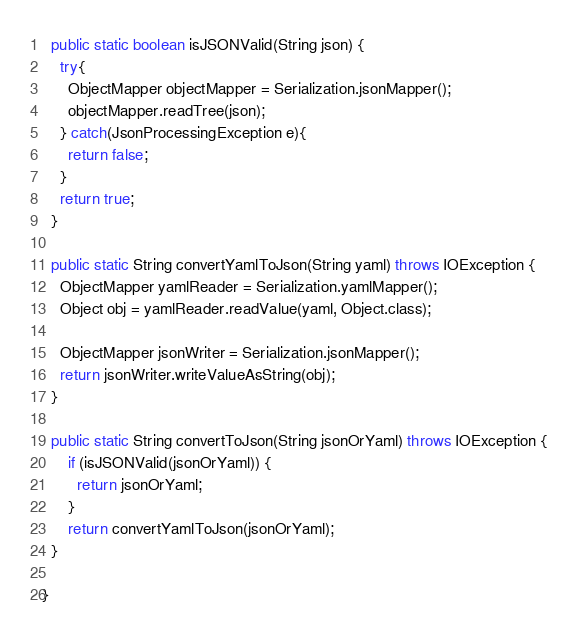Convert code to text. <code><loc_0><loc_0><loc_500><loc_500><_Java_>
  public static boolean isJSONValid(String json) {
    try{
      ObjectMapper objectMapper = Serialization.jsonMapper();
      objectMapper.readTree(json);
    } catch(JsonProcessingException e){
      return false;
    }
    return true;
  }

  public static String convertYamlToJson(String yaml) throws IOException {
    ObjectMapper yamlReader = Serialization.yamlMapper();
    Object obj = yamlReader.readValue(yaml, Object.class);

    ObjectMapper jsonWriter = Serialization.jsonMapper();
    return jsonWriter.writeValueAsString(obj);
  }

  public static String convertToJson(String jsonOrYaml) throws IOException {
      if (isJSONValid(jsonOrYaml)) {
        return jsonOrYaml;
      }
      return convertYamlToJson(jsonOrYaml);
  }

}
</code> 